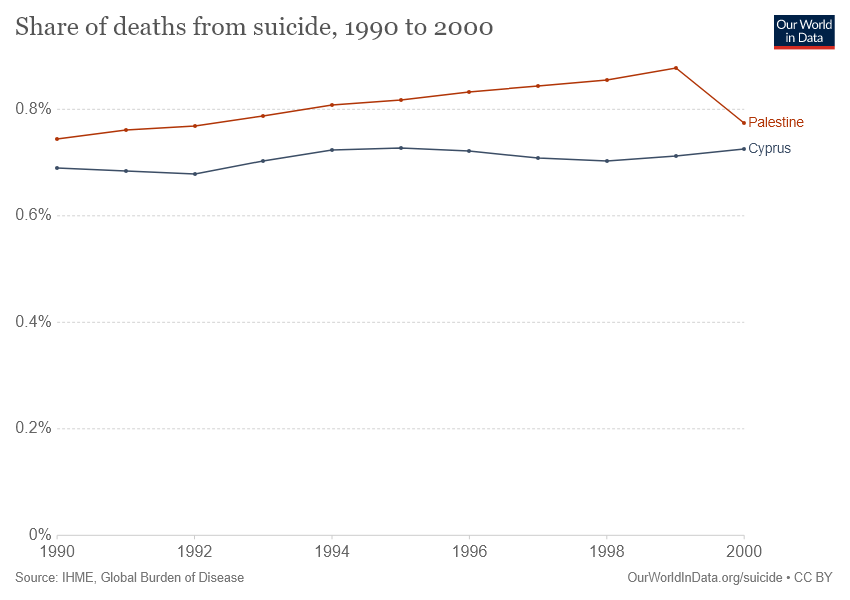Mention a couple of crucial points in this snapshot. The given graph compares Palestine and Cyprus. The country with the highest recorded share of deaths due to suicide over the years is Palestine. 